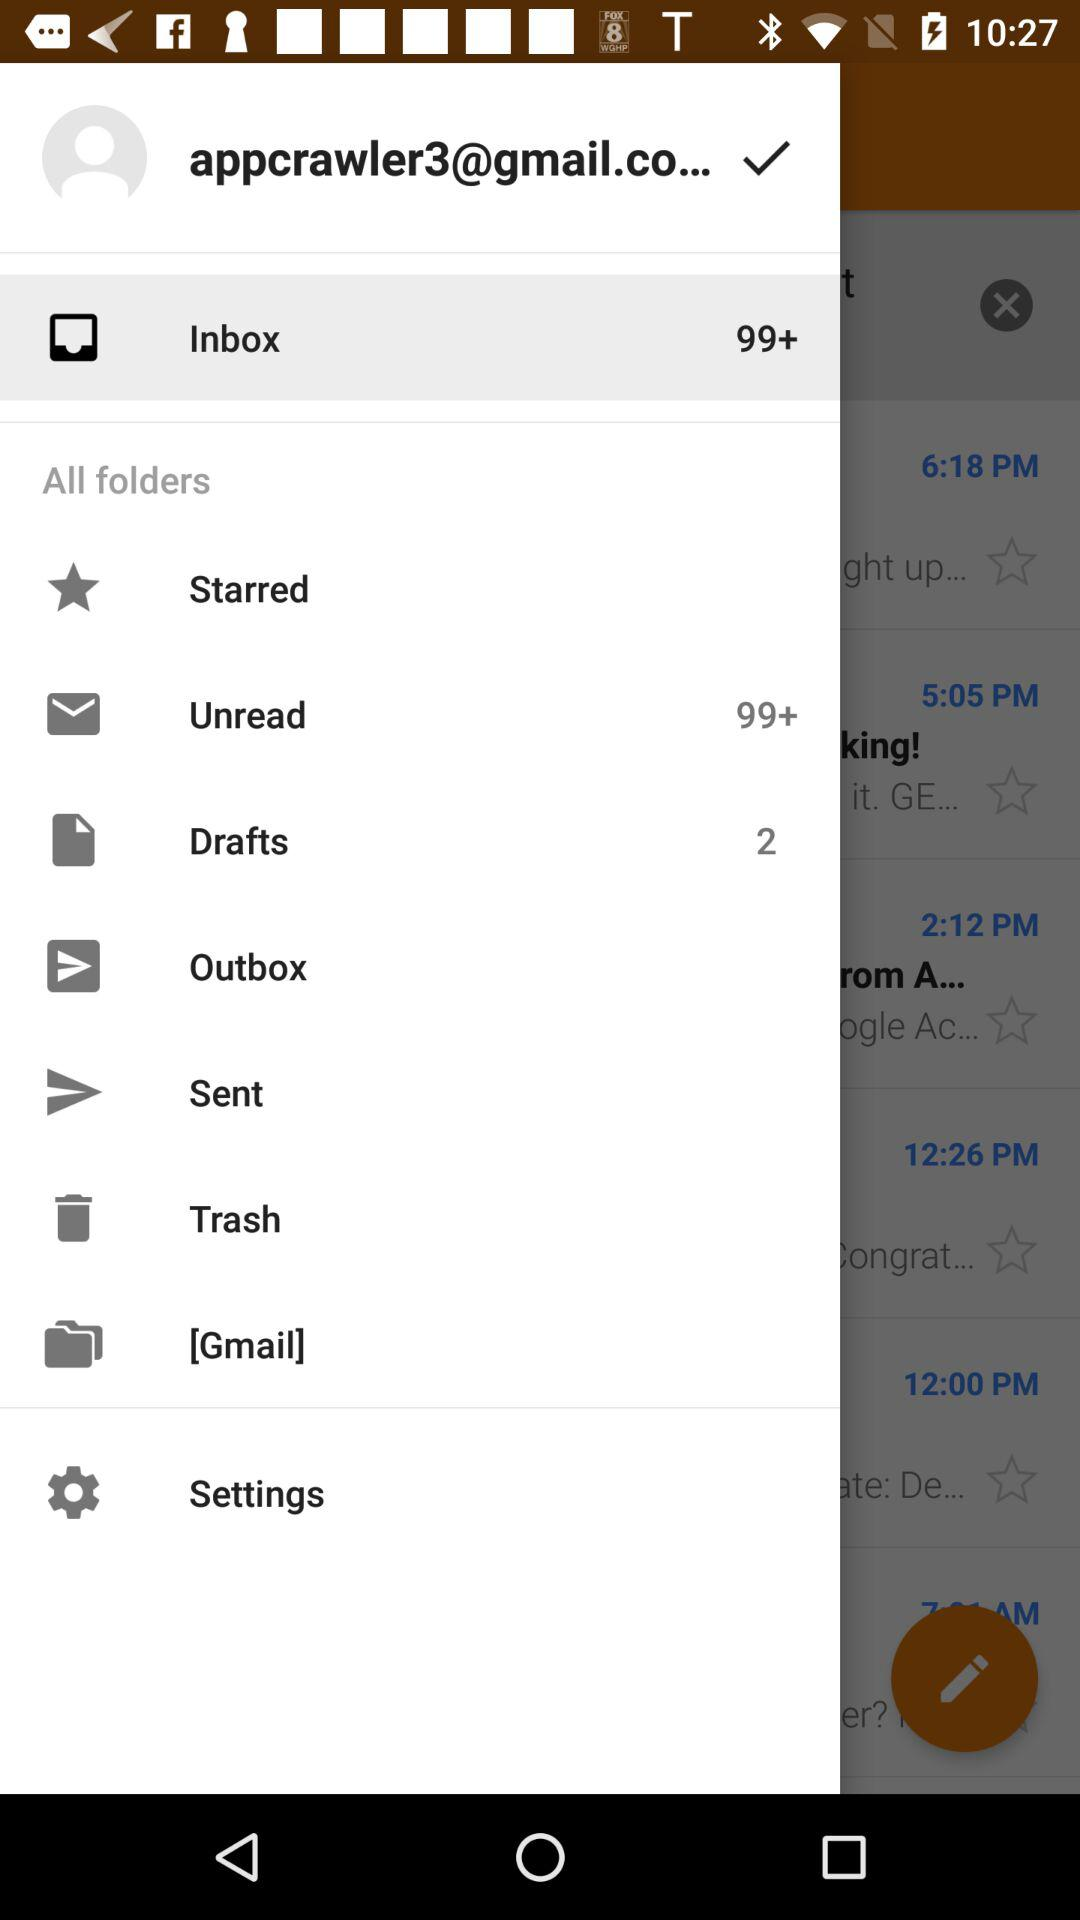How many unread mails are there in "Unread" folder? There are more than 99 unread mails in "Unread" folder. 